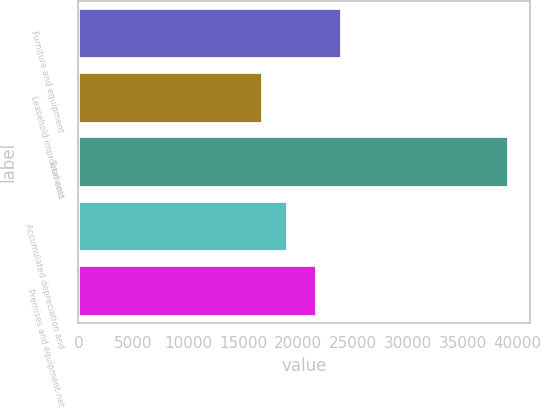<chart> <loc_0><loc_0><loc_500><loc_500><bar_chart><fcel>Furniture and equipment<fcel>Leasehold improvements<fcel>Total cost<fcel>Accumulated depreciation and<fcel>Premises and equipment-net<nl><fcel>23954.4<fcel>16806<fcel>39160<fcel>19041.4<fcel>21719<nl></chart> 